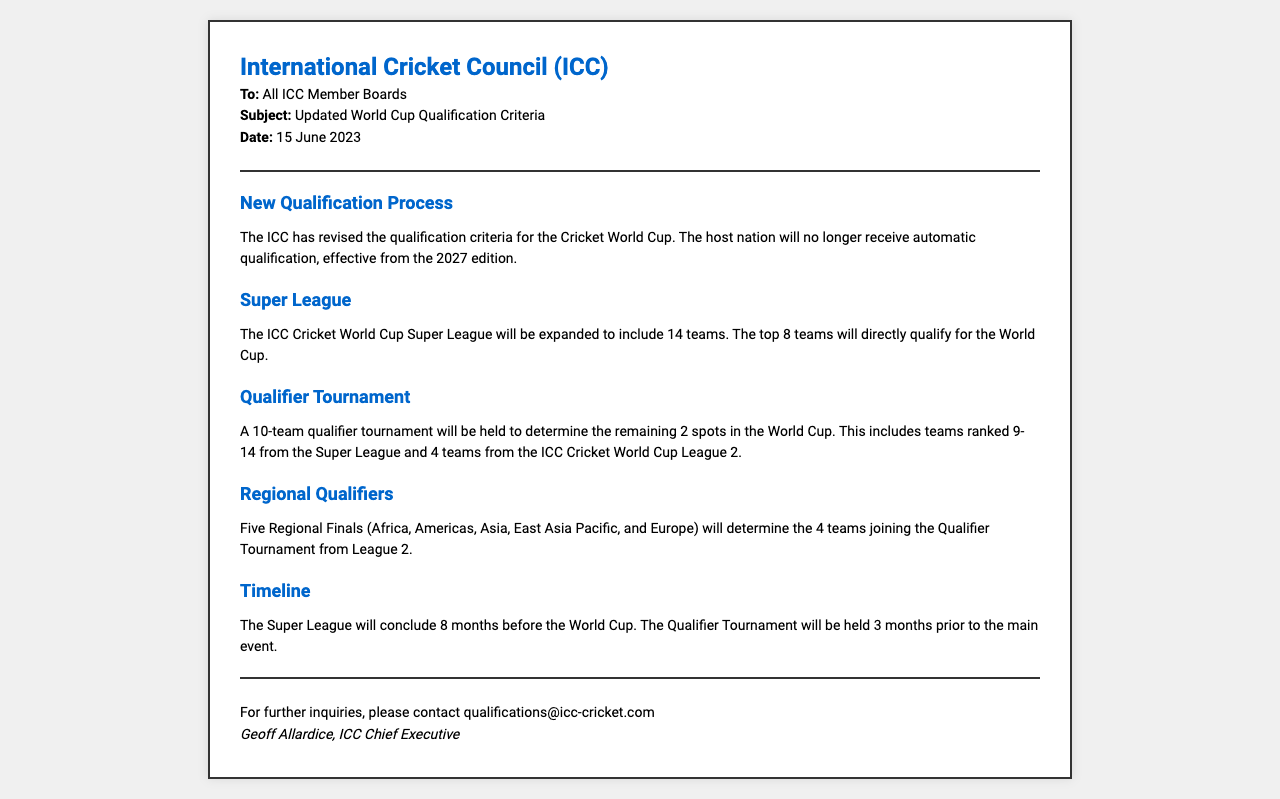What is the date of the fax? The date of the fax is mentioned in the document header.
Answer: 15 June 2023 Who is the sender of the fax? The sender of the fax is identified at the bottom of the document.
Answer: Geoff Allardice What teams are included in the Super League? The Super League consists of 14 teams, with specific qualification details outlined.
Answer: 14 teams How many teams will qualify directly for the World Cup? The document specifies the number of teams qualifying from the Super League for the World Cup.
Answer: 8 teams What is the total number of teams in the Qualifier Tournament? The document states how many teams will compete in the Qualifier Tournament.
Answer: 10 teams When will the Super League conclude? The conclusion of the Super League is tied to the World Cup timeline specified in the document.
Answer: 8 months before the World Cup How many Regional Finals will be held? The document details the number of Regional Finals in the qualification process.
Answer: 5 Regional Finals What will replace the automatic qualification for the host nation? The document indicates the change in qualification status for host nations starting in 2027.
Answer: No automatic qualification 